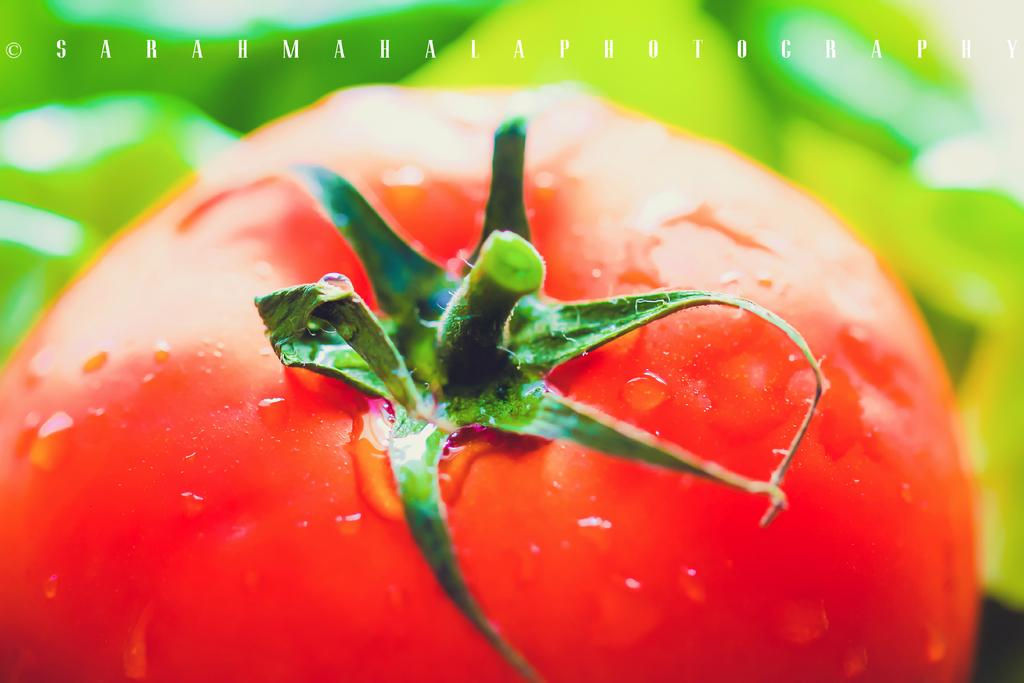What is the main subject in the foreground of the image? There is a tomato in the foreground of the image. What can be seen in the background of the image? There is a text visible in the background of the image. How would you describe the appearance of the background? The background has a colored appearance. What type of wine is being served in the library in the image? There is no wine or library present in the image; it features a tomato in the foreground and text in the background. 